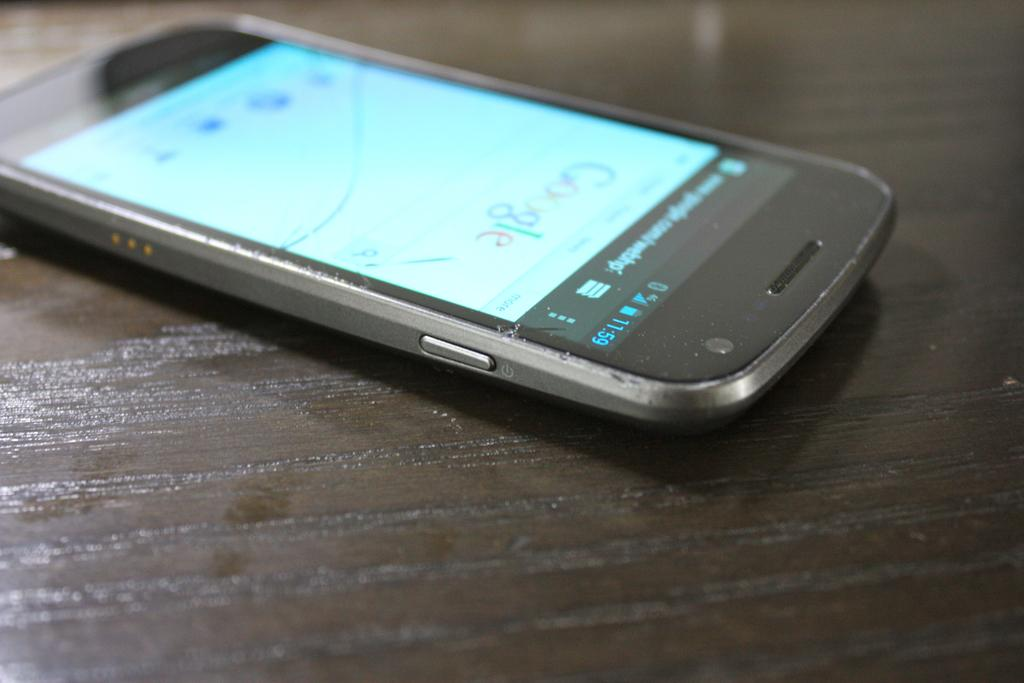<image>
Write a terse but informative summary of the picture. A phone on a table with the screen on Google home page. 